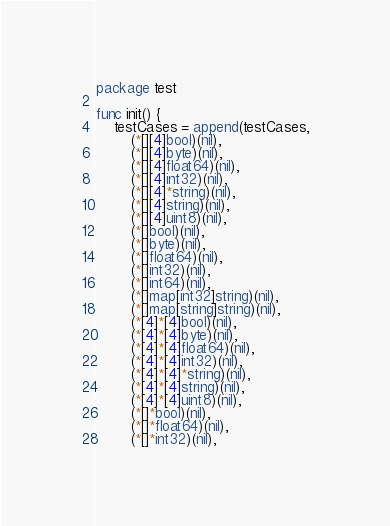Convert code to text. <code><loc_0><loc_0><loc_500><loc_500><_Go_>package test

func init() {
	testCases = append(testCases,
		(*[][4]bool)(nil),
		(*[][4]byte)(nil),
		(*[][4]float64)(nil),
		(*[][4]int32)(nil),
		(*[][4]*string)(nil),
		(*[][4]string)(nil),
		(*[][4]uint8)(nil),
		(*[]bool)(nil),
		(*[]byte)(nil),
		(*[]float64)(nil),
		(*[]int32)(nil),
		(*[]int64)(nil),
		(*[]map[int32]string)(nil),
		(*[]map[string]string)(nil),
		(*[4]*[4]bool)(nil),
		(*[4]*[4]byte)(nil),
		(*[4]*[4]float64)(nil),
		(*[4]*[4]int32)(nil),
		(*[4]*[4]*string)(nil),
		(*[4]*[4]string)(nil),
		(*[4]*[4]uint8)(nil),
		(*[]*bool)(nil),
		(*[]*float64)(nil),
		(*[]*int32)(nil),</code> 